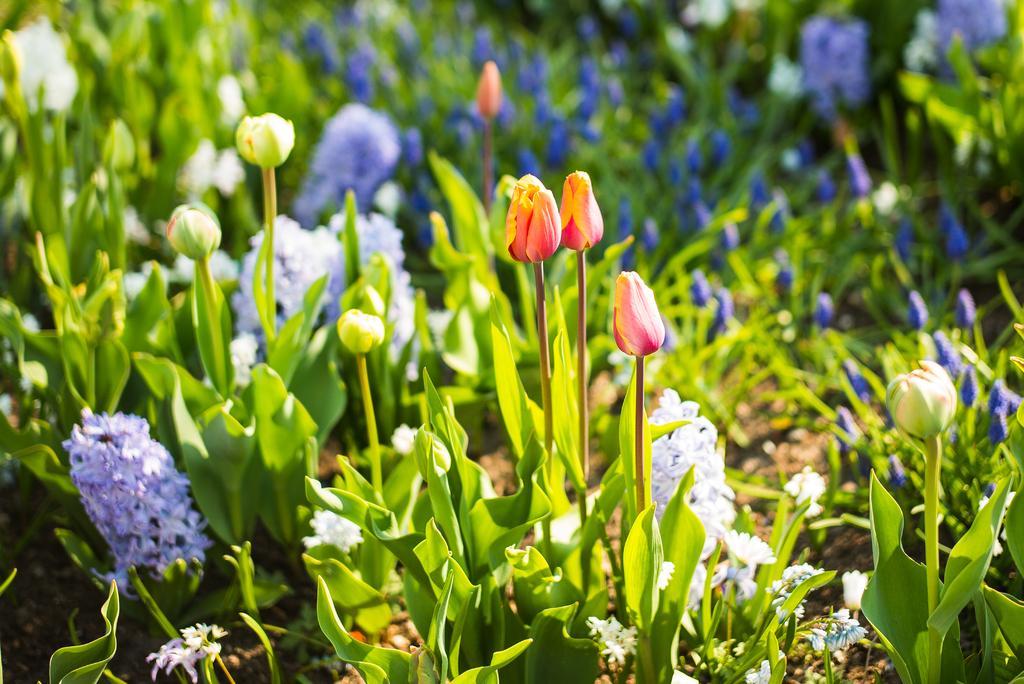Describe this image in one or two sentences. In this picture we can see a few colorful flowers throughout the image. Background is blurry. 